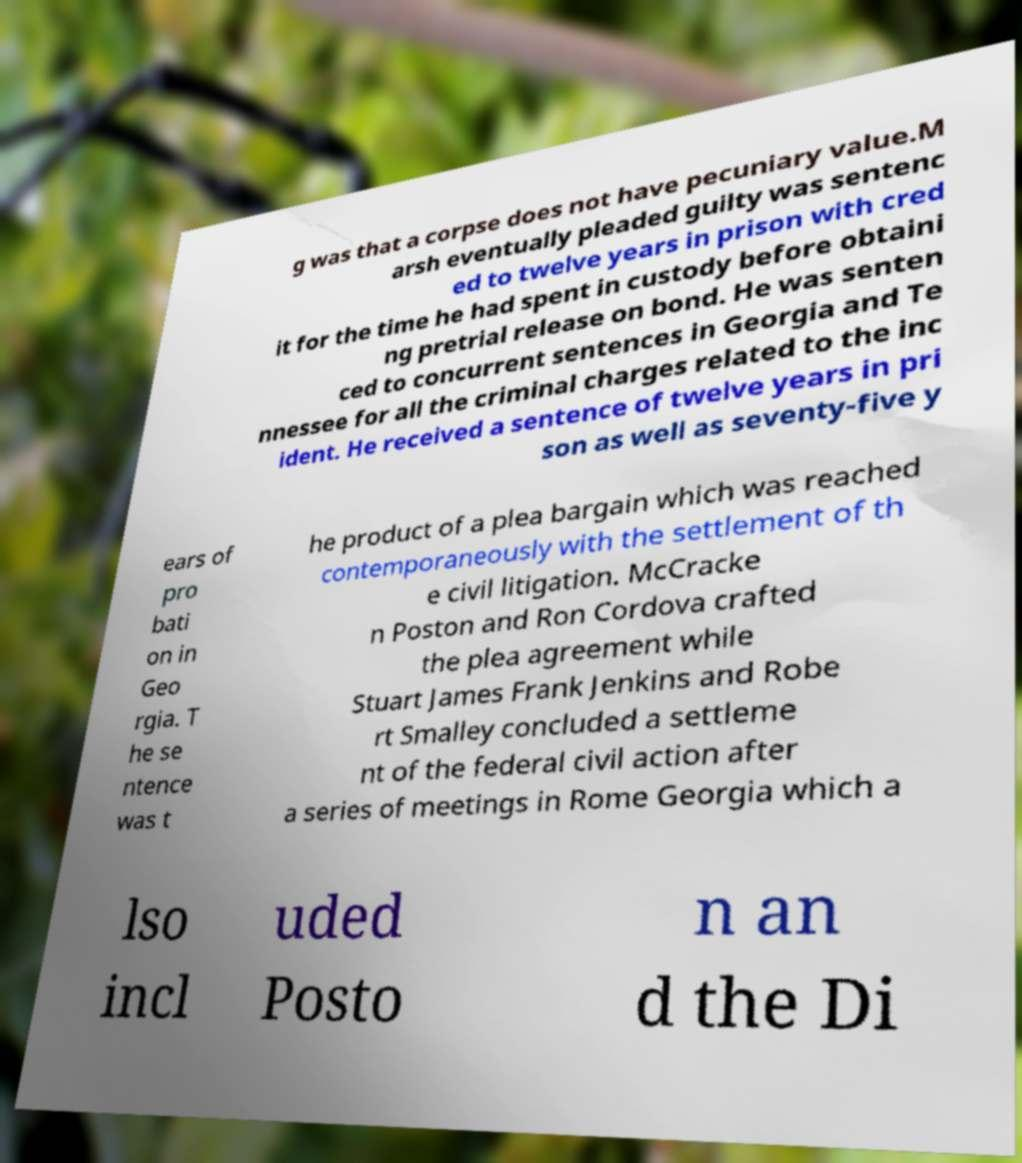What messages or text are displayed in this image? I need them in a readable, typed format. g was that a corpse does not have pecuniary value.M arsh eventually pleaded guilty was sentenc ed to twelve years in prison with cred it for the time he had spent in custody before obtaini ng pretrial release on bond. He was senten ced to concurrent sentences in Georgia and Te nnessee for all the criminal charges related to the inc ident. He received a sentence of twelve years in pri son as well as seventy-five y ears of pro bati on in Geo rgia. T he se ntence was t he product of a plea bargain which was reached contemporaneously with the settlement of th e civil litigation. McCracke n Poston and Ron Cordova crafted the plea agreement while Stuart James Frank Jenkins and Robe rt Smalley concluded a settleme nt of the federal civil action after a series of meetings in Rome Georgia which a lso incl uded Posto n an d the Di 